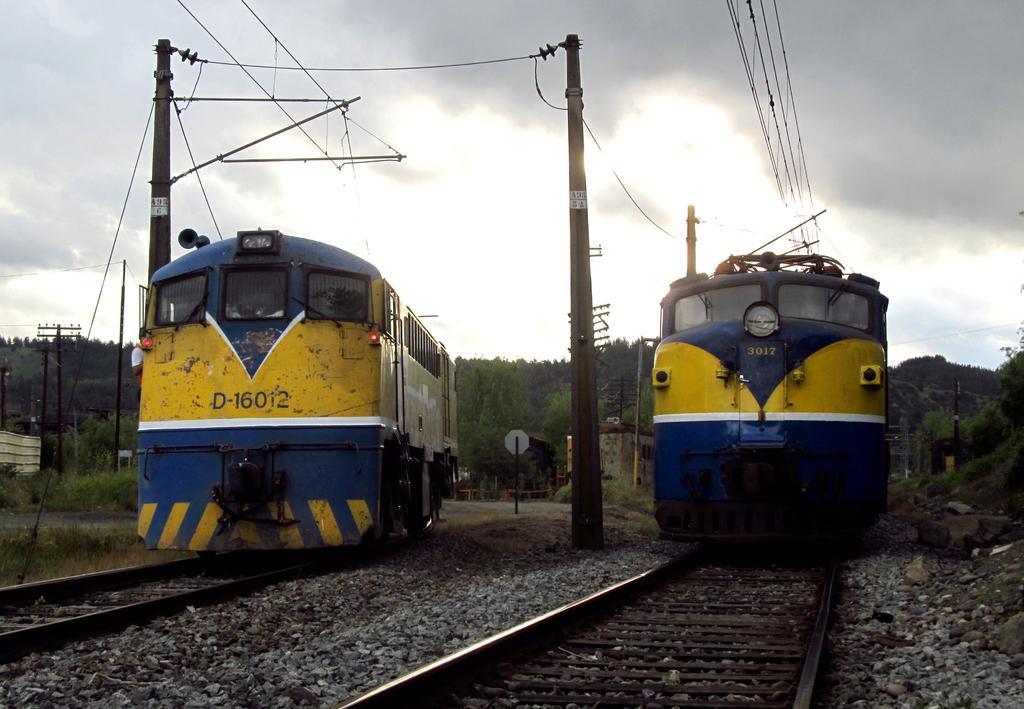Please provide a concise description of this image. This is the picture of a railway station. In this image there are two trains on the railway track. At the back there are poles, buildings and trees. At the top there is sky and there are clouds and wires. At the bottom there are stones and railway tracks. 